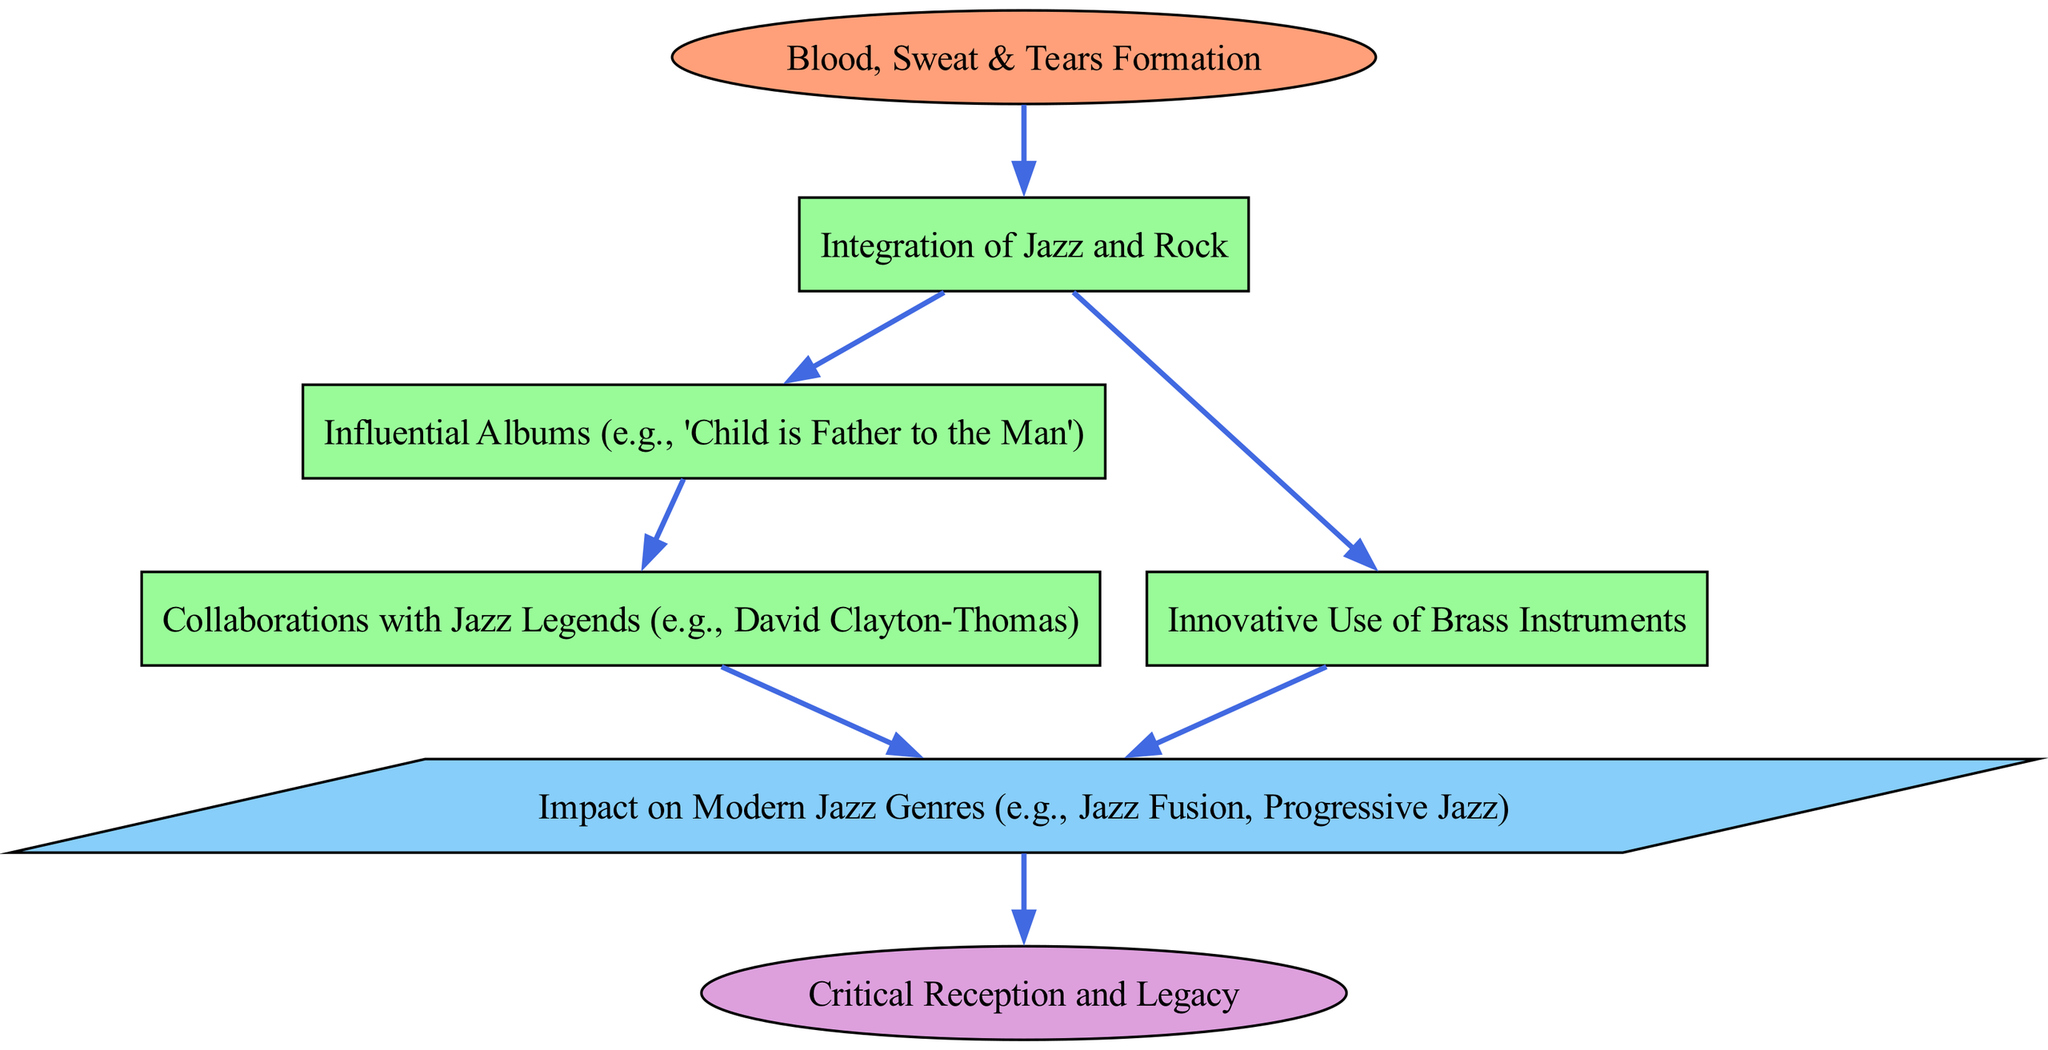What is the starting point of the flow chart? The starting point is indicated as "Blood, Sweat & Tears Formation," which is the initial node in the diagram representing the beginning of the analysis.
Answer: Blood, Sweat & Tears Formation How many process nodes are there in the diagram? By counting the nodes labeled as "Process," we find there are four such nodes: "Integration of Jazz and Rock," "Influential Albums," "Innovative Use of Brass Instruments," and "Collaborations with Jazz Legends."
Answer: Four What is the final output of the flow chart? The final output is indicated as "Impact on Modern Jazz Genres," which represents the important result of the preceding processes in the flow chart.
Answer: Impact on Modern Jazz Genres What process follows "Integration of Jazz and Rock"? The process that follows is "Influential Albums (e.g., 'Child is Father to the Man')," which is directly connected to the "Integration of Jazz and Rock" node.
Answer: Influential Albums (e.g., 'Child is Father to the Man') What is the outcome of both "Innovative Use of Brass Instruments" and "Collaborations with Jazz Legends"? Both connect to the same output node: "Impact on Modern Jazz Genres," indicating that they contribute to this outcome.
Answer: Impact on Modern Jazz Genres Which node is connected to the "Critical Reception and Legacy"? The node that connects to "Critical Reception and Legacy" is the "Impact on Modern Jazz Genres," which shows the flow from the outcomes to the eventual evaluation of the contributions.
Answer: Impact on Modern Jazz Genres What are two influential figures mentioned in the process nodes? The two influential figures referenced in the process nodes are "David Clayton-Thomas" from the "Collaborations with Jazz Legends" and "Blood, Sweat & Tears."
Answer: David Clayton-Thomas, Blood, Sweat & Tears How does "Innovative Use of Brass Instruments" relate to the output? "Innovative Use of Brass Instruments" directly leads to the output node, showing that this aspect of Blood, Sweat & Tears plays a role in shaping modern jazz genres.
Answer: It directly leads to the output 